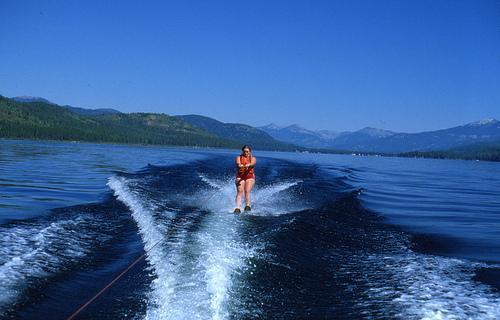How many people are there?
Give a very brief answer. 1. 